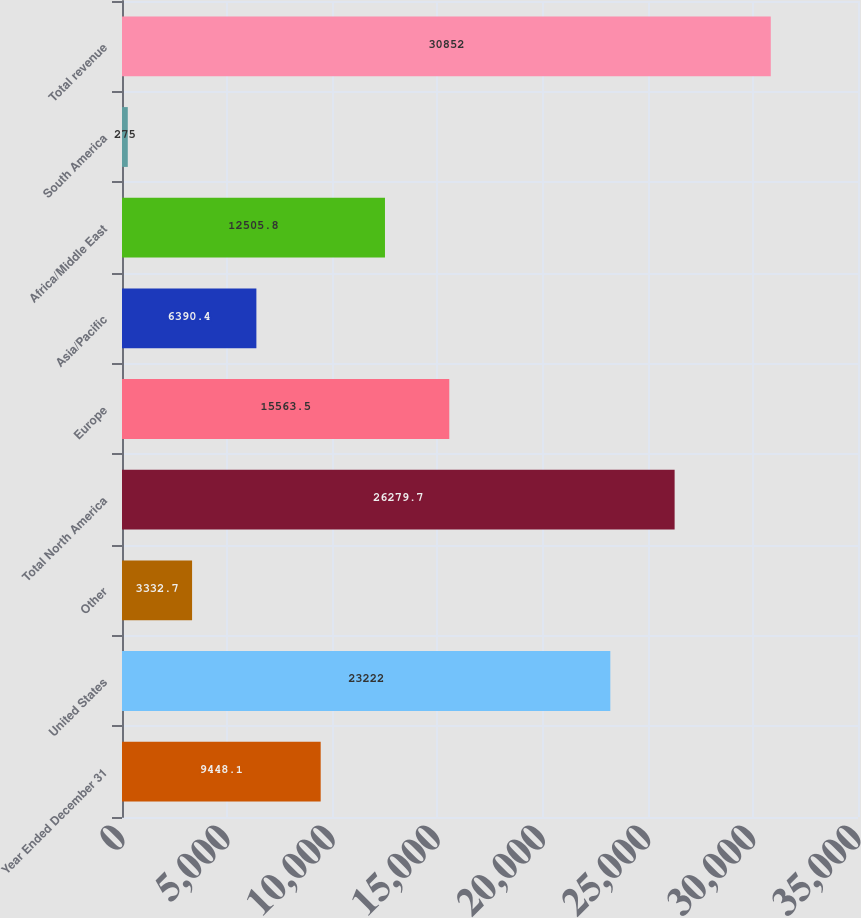<chart> <loc_0><loc_0><loc_500><loc_500><bar_chart><fcel>Year Ended December 31<fcel>United States<fcel>Other<fcel>Total North America<fcel>Europe<fcel>Asia/Pacific<fcel>Africa/Middle East<fcel>South America<fcel>Total revenue<nl><fcel>9448.1<fcel>23222<fcel>3332.7<fcel>26279.7<fcel>15563.5<fcel>6390.4<fcel>12505.8<fcel>275<fcel>30852<nl></chart> 